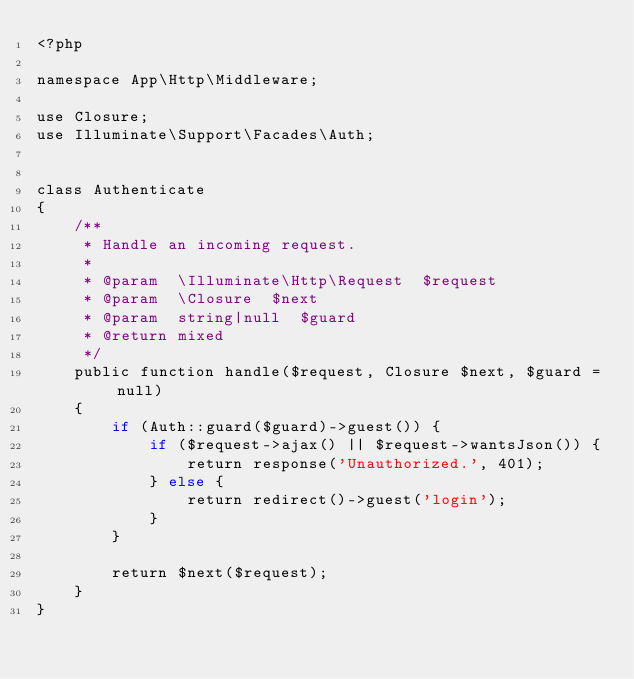Convert code to text. <code><loc_0><loc_0><loc_500><loc_500><_PHP_><?php

namespace App\Http\Middleware;

use Closure;
use Illuminate\Support\Facades\Auth;


class Authenticate
{
    /**
     * Handle an incoming request.
     *
     * @param  \Illuminate\Http\Request  $request
     * @param  \Closure  $next
     * @param  string|null  $guard
     * @return mixed
     */
    public function handle($request, Closure $next, $guard = null)
    {
        if (Auth::guard($guard)->guest()) {
            if ($request->ajax() || $request->wantsJson()) {
                return response('Unauthorized.', 401);
            } else {
                return redirect()->guest('login');
            }
        }

        return $next($request);
    }
}
</code> 